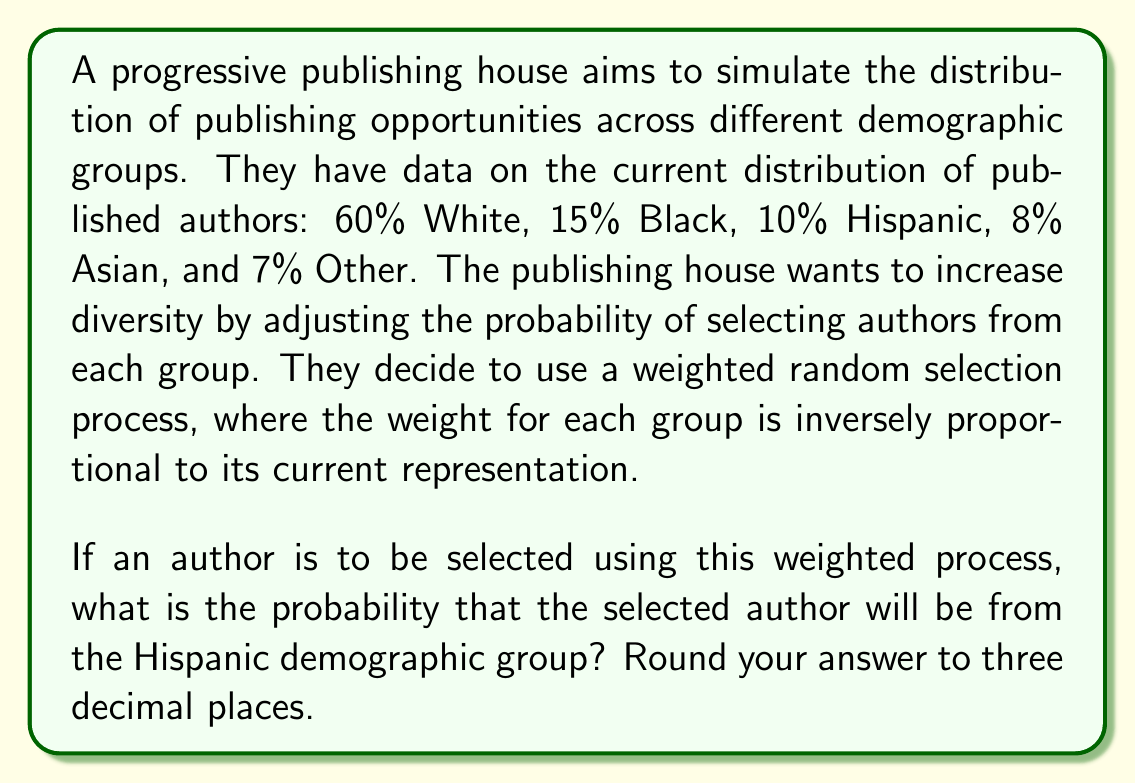Give your solution to this math problem. Let's approach this step-by-step:

1) First, we need to calculate the weights for each group. The weight is inversely proportional to the current representation, so we'll use the reciprocal of the current percentages:

   White: $1/0.60 = 1.67$
   Black: $1/0.15 = 6.67$
   Hispanic: $1/0.10 = 10.00$
   Asian: $1/0.08 = 12.50$
   Other: $1/0.07 = 14.29$

2) Now, we need to sum these weights to get the total:

   $1.67 + 6.67 + 10.00 + 12.50 + 14.29 = 45.13$

3) The probability of selecting an author from a specific group is the weight of that group divided by the total weight. For the Hispanic group:

   $$P(\text{Hispanic}) = \frac{10.00}{45.13}$$

4) Calculating this:

   $$P(\text{Hispanic}) = 0.2215...$$

5) Rounding to three decimal places:

   $$P(\text{Hispanic}) = 0.222$$
Answer: 0.222 